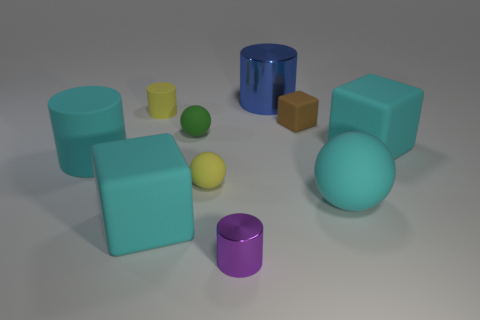Subtract all purple cylinders. How many cylinders are left? 3 Subtract all cyan balls. How many balls are left? 2 Subtract all balls. How many objects are left? 7 Add 3 yellow rubber things. How many yellow rubber things are left? 5 Add 3 small green objects. How many small green objects exist? 4 Subtract 0 red blocks. How many objects are left? 10 Subtract 1 blocks. How many blocks are left? 2 Subtract all blue spheres. Subtract all yellow cylinders. How many spheres are left? 3 Subtract all purple cylinders. How many cyan spheres are left? 1 Subtract all tiny cyan metallic cylinders. Subtract all small things. How many objects are left? 5 